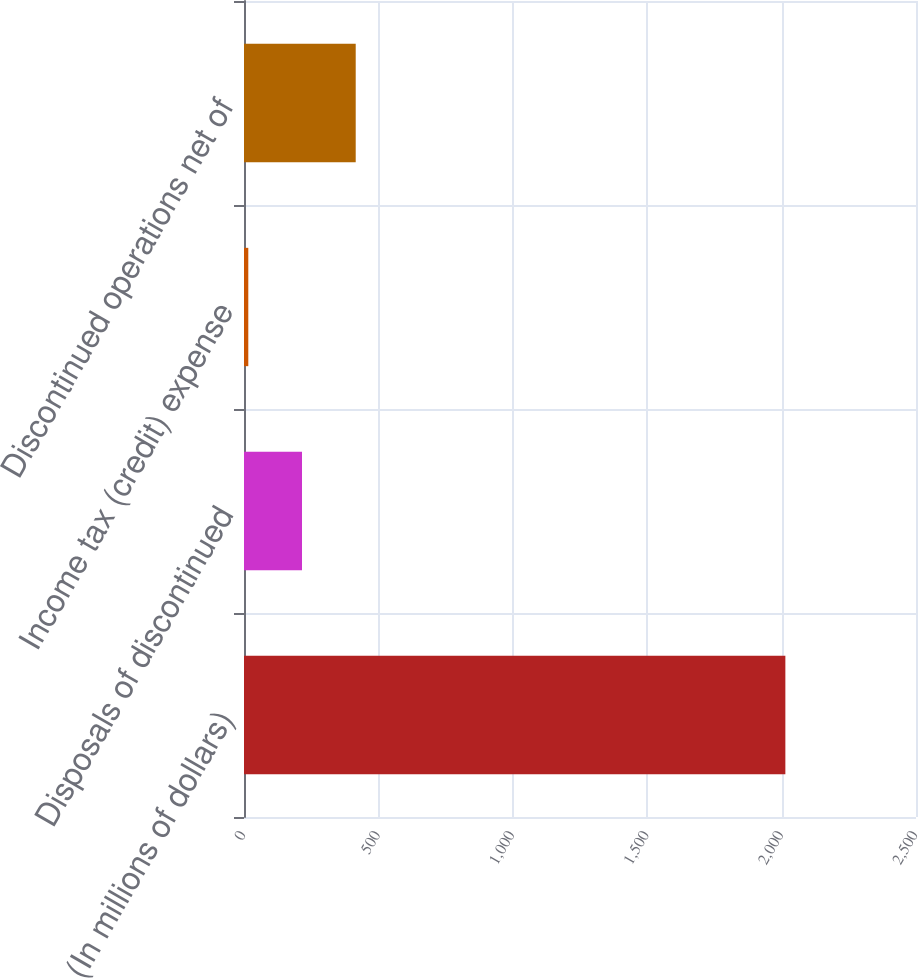Convert chart to OTSL. <chart><loc_0><loc_0><loc_500><loc_500><bar_chart><fcel>(In millions of dollars)<fcel>Disposals of discontinued<fcel>Income tax (credit) expense<fcel>Discontinued operations net of<nl><fcel>2014<fcel>215.8<fcel>16<fcel>415.6<nl></chart> 